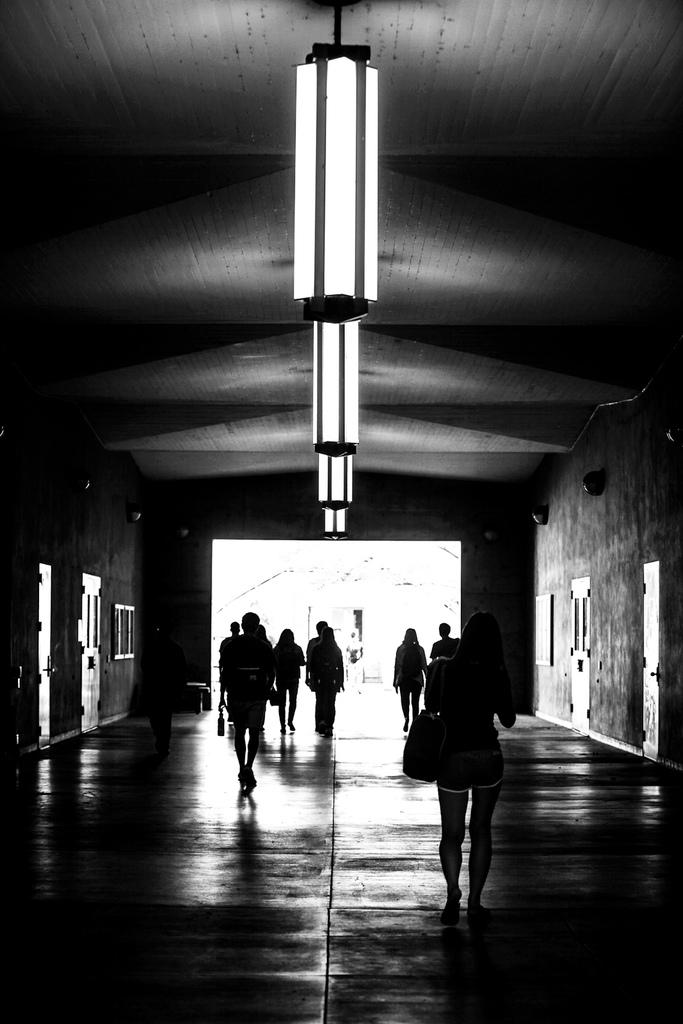What are the people in the image doing? The people in the image are walking. Where are the people walking? The people are walking on a path. What can be seen hanging from the ceiling in the image? There are lights hanging from the ceiling in the image. What is present on either side of the path? There are walls on either side of the path, and there are doors on either side as well. What type of pain is the person experiencing while walking in the image? There is no indication of pain in the image; the people are simply walking on a path. 